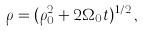Convert formula to latex. <formula><loc_0><loc_0><loc_500><loc_500>\rho = ( \rho _ { 0 } ^ { 2 } + 2 \Omega _ { 0 } t ) ^ { 1 / 2 } \, ,</formula> 